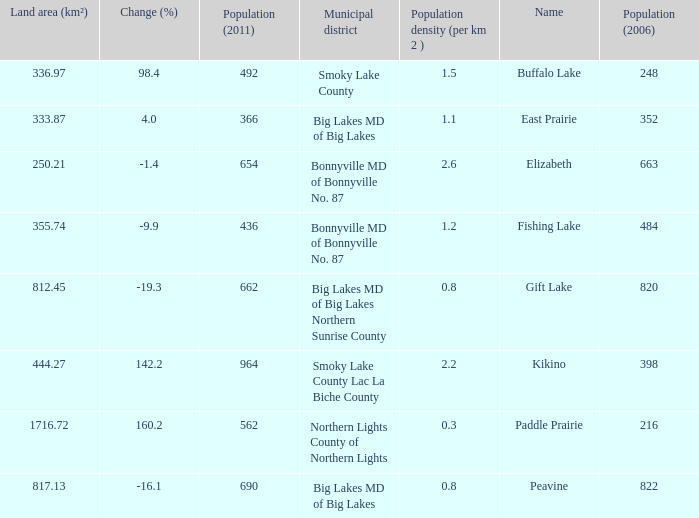What is the population per km2 in Fishing Lake? 1.2. 